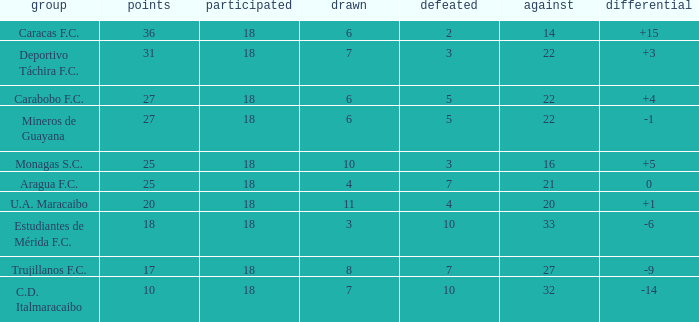What is the average against score of all teams with less than 7 losses, more than 6 draws, and 25 points? 16.0. 